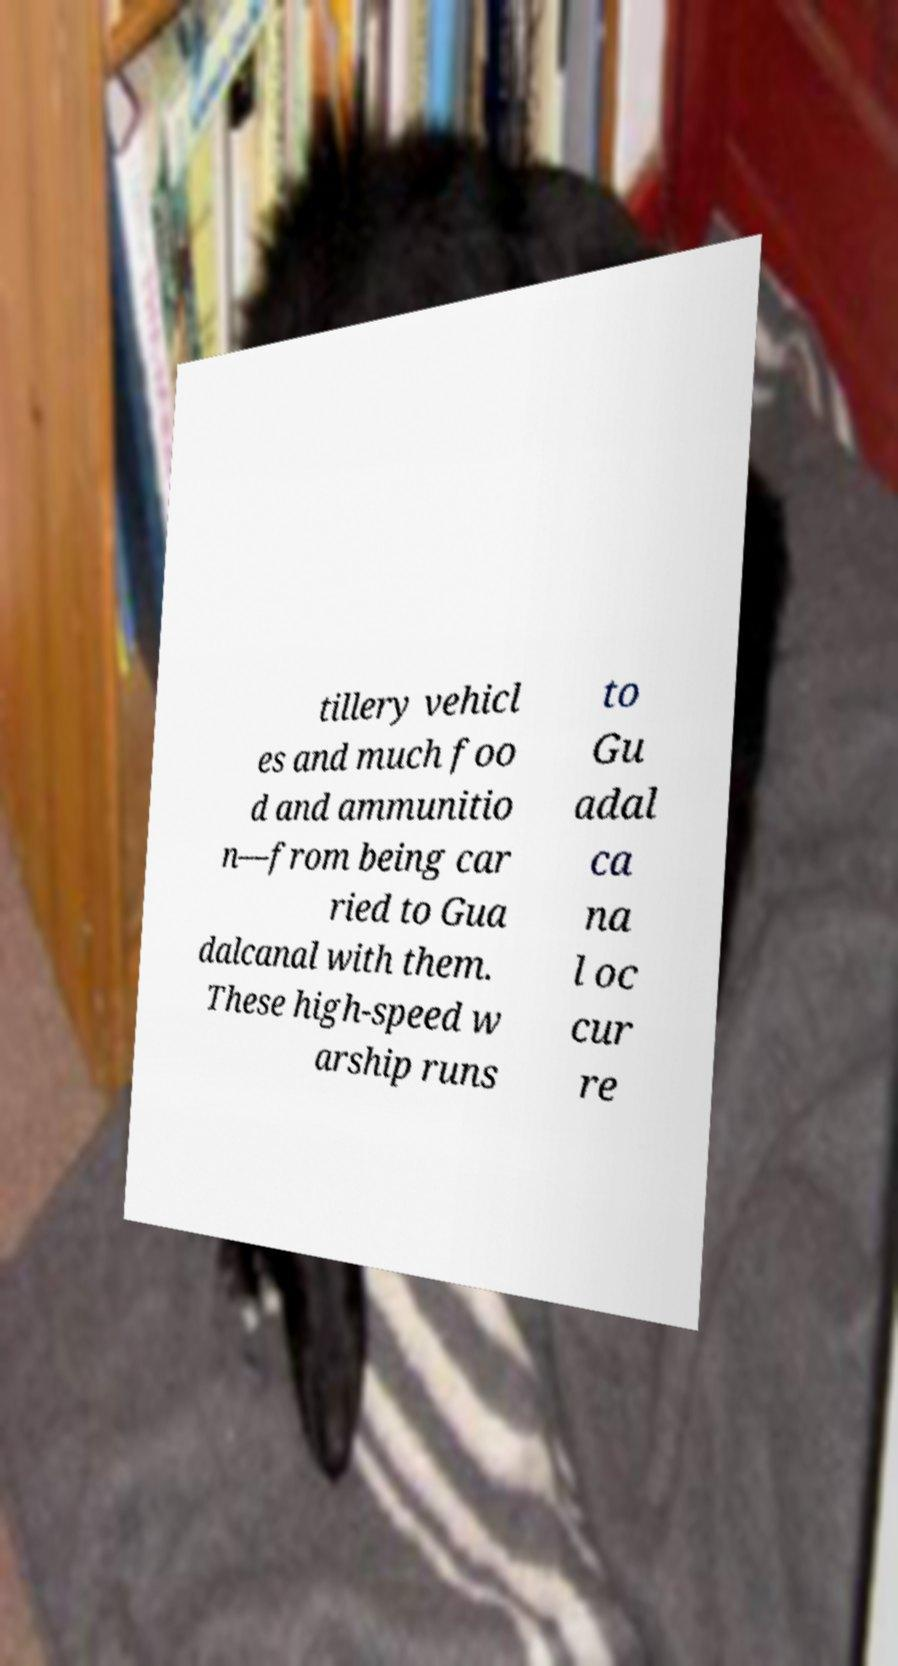What messages or text are displayed in this image? I need them in a readable, typed format. tillery vehicl es and much foo d and ammunitio n—from being car ried to Gua dalcanal with them. These high-speed w arship runs to Gu adal ca na l oc cur re 